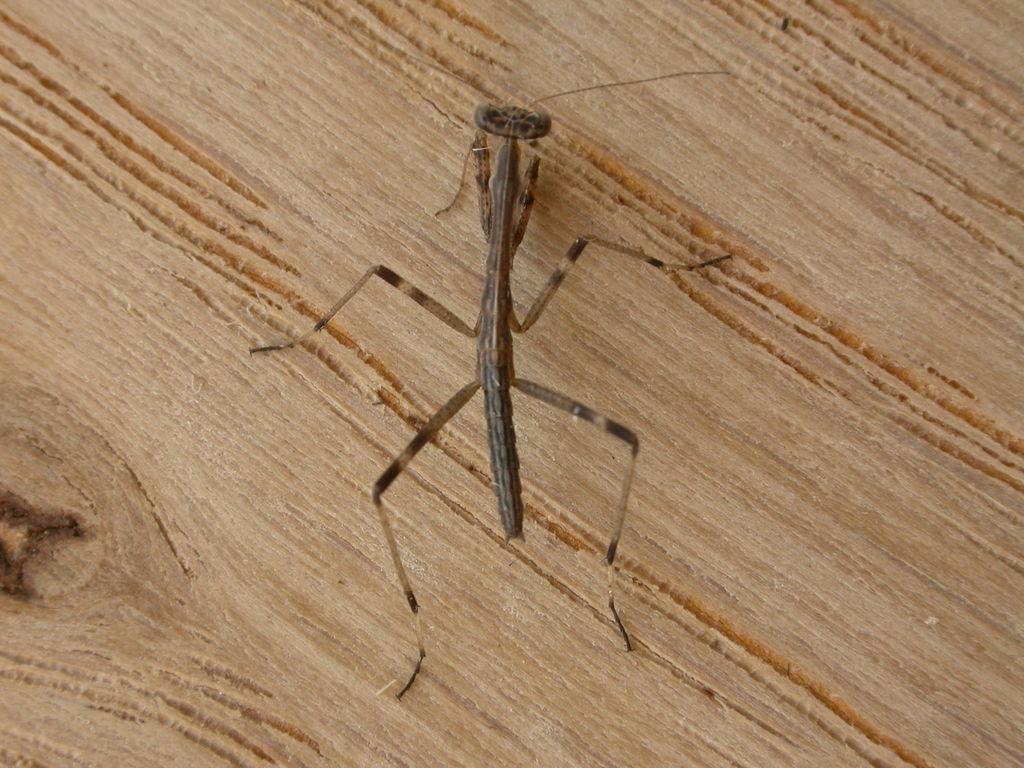Can you describe this image briefly? In this image I can see in the middle there is an insect on the wood. 